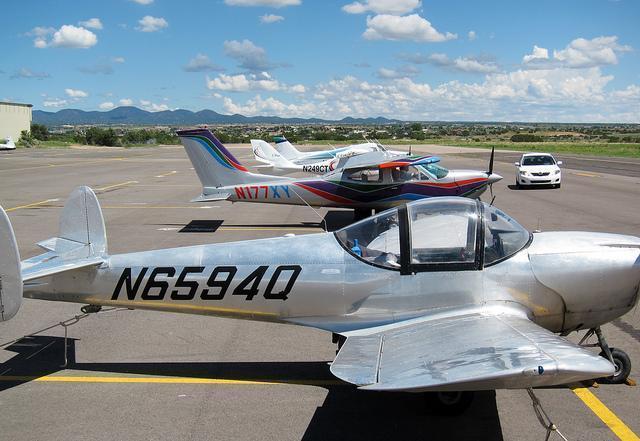What are cables hooked to these planes for?
Choose the correct response and explain in the format: 'Answer: answer
Rationale: rationale.'
Options: Kite flying, sales gimmick, holding steady, racing feature. Answer: holding steady.
Rationale: The cables hold it steady. 